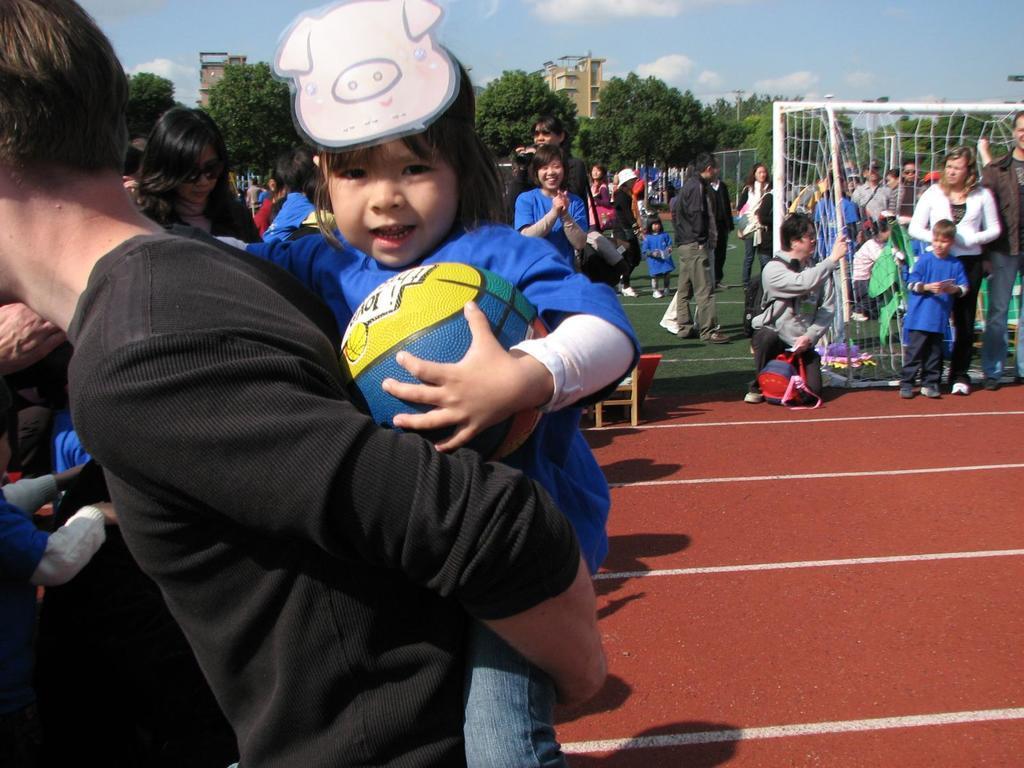Can you describe this image briefly? In this image there are group of people some of them are standing and some of them are walking and on the top there is sky and in the center there are some trees and buildings are there and on the top of the right side there is a net. 